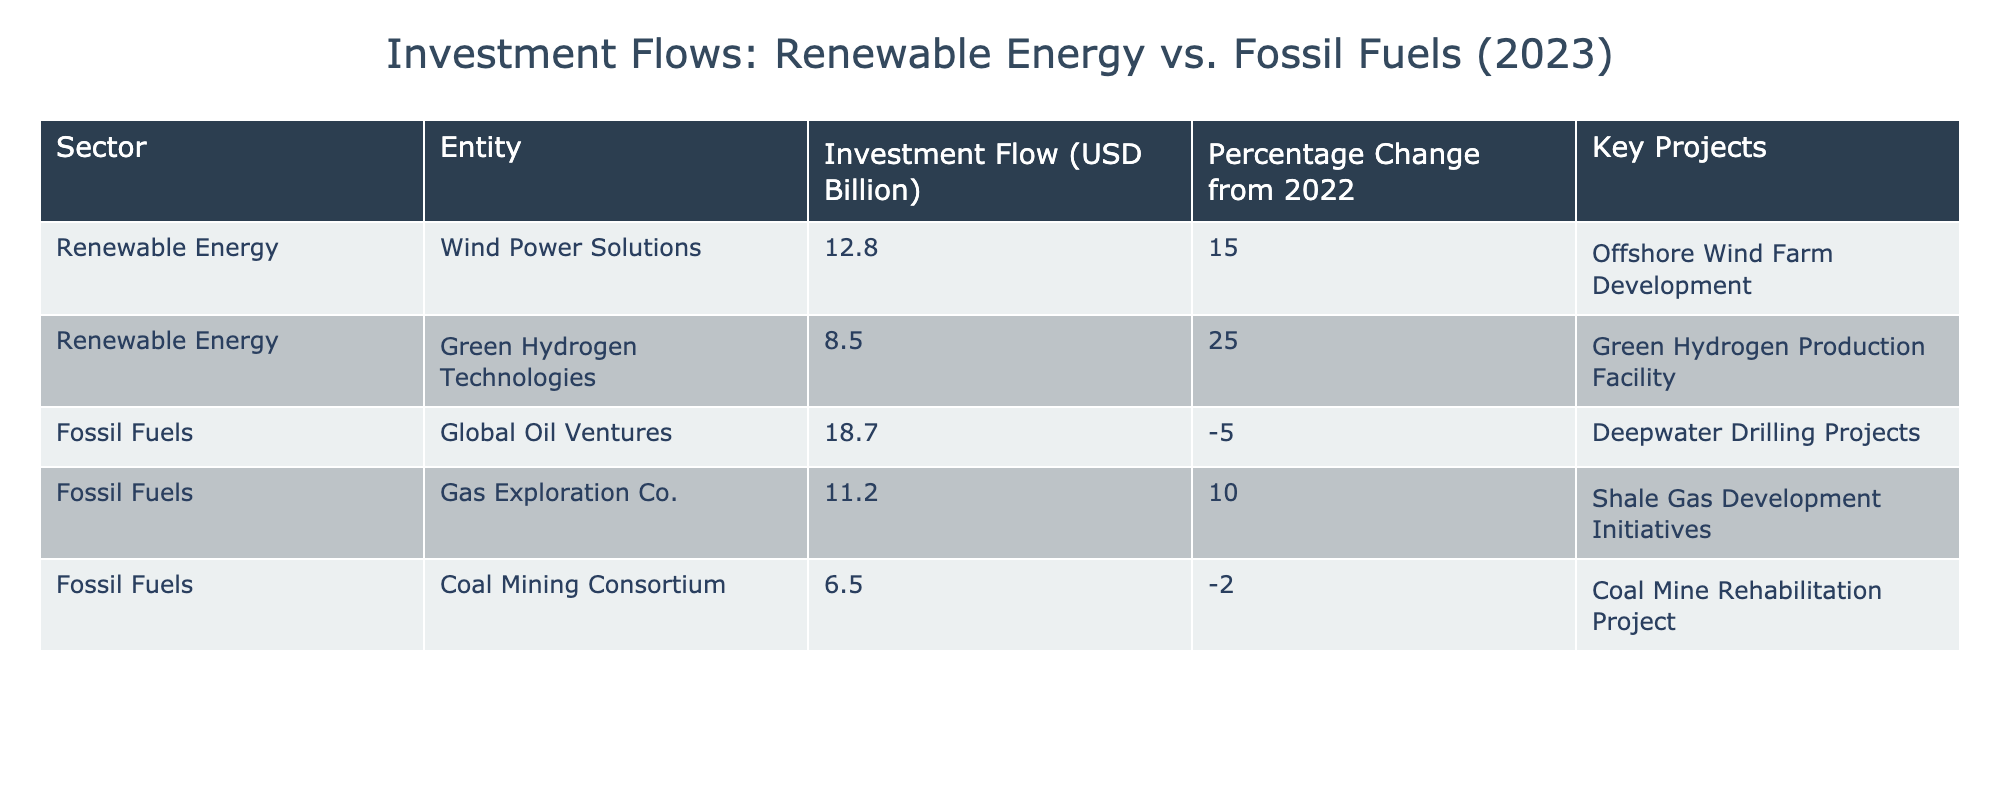What is the total investment flow into renewable energy? The table lists two entries under renewable energy with the investment flows of 12.8 billion and 8.5 billion. Adding these values together gives a total of 12.8 + 8.5 = 21.3 billion.
Answer: 21.3 billion What was the percentage change in investment for Gas Exploration Co. from 2022? Looking at the table, the investment flow’s percentage change for Gas Exploration Co. is explicitly listed as 10%.
Answer: 10% Is the investment flow into Wind Power Solutions higher than that into Coal Mining Consortium? The investment flow into Wind Power Solutions is 12.8 billion while that into Coal Mining Consortium is 6.5 billion. Since 12.8 billion is greater than 6.5 billion, the statement is true.
Answer: Yes What is the combined investment flow for fossil fuels? The table shows three entries for fossil fuels with investment flows of 18.7 billion, 11.2 billion, and 6.5 billion. Adding these amounts gives 18.7 + 11.2 + 6.5 = 36.4 billion.
Answer: 36.4 billion Which sector had a higher total investment flow, renewable energy or fossil fuels? The total investment for renewable energy is 21.3 billion, and for fossil fuels, it is 36.4 billion. Since 36.4 billion is greater than 21.3 billion, fossil fuels had the higher investment flow.
Answer: Fossil fuels Was there any investment flow in the fossil fuel sector that experienced a positive percentage change? The entry for Gas Exploration Co. shows a 10% increase in its investment flow, while Global Oil Ventures experienced a decrease of 5% and Coal Mining Consortium had a decrease of 2%. Thus, there was indeed at least one investment with a positive change.
Answer: Yes What is the median investment flow of all entities listed in the table? First, we need to list all investment flows: 12.8, 8.5, 18.7, 11.2, and 6.5. When sorted, these values are 6.5, 8.5, 11.2, 12.8, and 18.7. The median is the middle value, which in this case is 11.2.
Answer: 11.2 Which key project has the highest associated investment flow? The investment flows linked to projects are 12.8 billion for Offshore Wind Farm Development, 8.5 billion for Green Hydrogen Production Facility, 18.7 billion for Deepwater Drilling Projects, 11.2 billion for Shale Gas Development Initiatives, and 6.5 billion for Coal Mine Rehabilitation Project. The highest investment flow is 18.7 billion.
Answer: Deepwater Drilling Projects How much did investment in Green Hydrogen Technologies change from 2022? The investment flow for Green Hydrogen Technologies had a percentage change listed as 25%. This indicates a significant increase compared to 2022.
Answer: 25% 